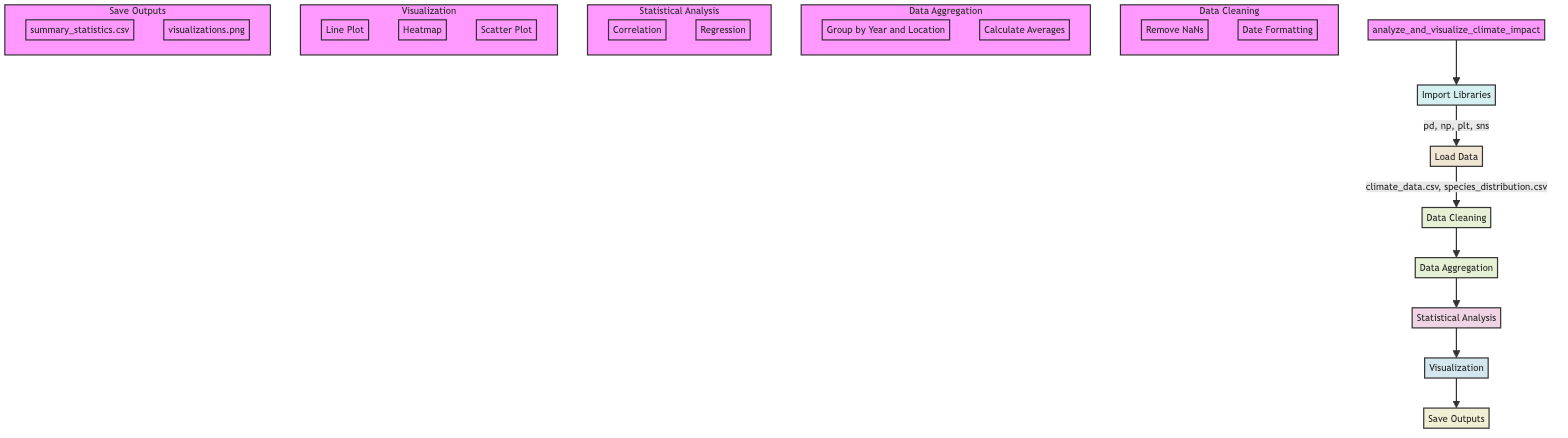What is the first step in the flowchart? The flowchart shows that the very first step is "Import Libraries". This is indicated as the first node connected to the main function.
Answer: Import Libraries How many datasets are loaded in the Load Data step? There are two datasets mentioned in the Load Data step: "climate_data.csv" and "species_distribution.csv". This is directly observed in the relative attributes of the Load Data node.
Answer: Two What is the action taken during Data Cleaning? The Data Cleaning step includes two specific actions: "Remove NaNs" and "Date Formatting". These are detailed as sub-steps within the Data Cleaning section in the diagram.
Answer: Remove NaNs, Date Formatting Which plot type is used to show trends in temperature and species counts? The visualization step includes a "Line Plot" specifically designated for showing trends in temperature and species counts over time. This information is provided under the Visualization node.
Answer: Line Plot What is the last action taken in the flowchart? The last action listed in the flowchart is "Save Outputs", which indicates that after all analyses and visualizations, outputs are saved. This is clearly illustrated as the final step connected to the previous steps.
Answer: Save Outputs Which statistical analysis techniques are performed? In the Statistical Analysis step of the flowchart, two techniques are performed: "Correlation" and "Regression". These are illustrated as sub-steps under the Statistical Analysis node.
Answer: Correlation, Regression What type of output is "visualizations.png"? "visualizations.png" is a file type indicated in the Save Outputs section, and it is described as saving the generated plots as an image. This is represented in the last node of the flowchart.
Answer: PNG How does Data Aggregation depend on Data Cleaning? Data Aggregation is dependent on Data Cleaning, as the output of the Data Cleaning step directly feeds into the Data Aggregation step. This sequential relationship reflects the need for cleaned data before aggregation occurs in the flowchart.
Answer: Sequential Dependency What actions are taken for data aggregation? The Data Aggregation step involves two main actions: "Group by Year and Location" and "Calculate Averages". These actions are explicitly listed under the Data Aggregation node in the diagram.
Answer: Group by Year and Location, Calculate Averages 